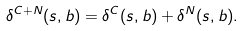Convert formula to latex. <formula><loc_0><loc_0><loc_500><loc_500>\delta ^ { C + N } ( s , b ) = \delta ^ { C } ( s , b ) + \delta ^ { N } ( s , b ) .</formula> 